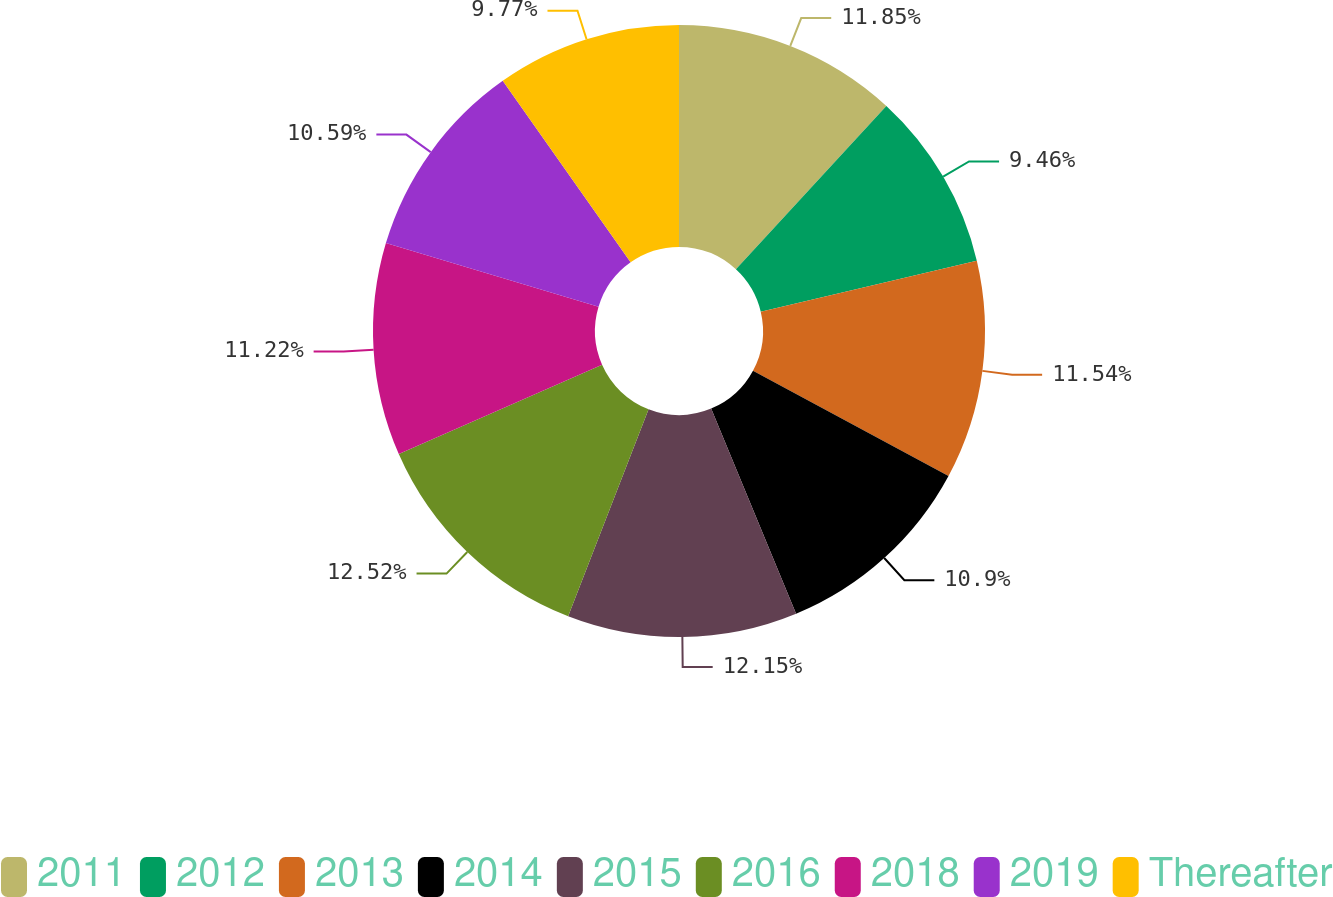<chart> <loc_0><loc_0><loc_500><loc_500><pie_chart><fcel>2011<fcel>2012<fcel>2013<fcel>2014<fcel>2015<fcel>2016<fcel>2018<fcel>2019<fcel>Thereafter<nl><fcel>11.85%<fcel>9.46%<fcel>11.54%<fcel>10.9%<fcel>12.15%<fcel>12.52%<fcel>11.22%<fcel>10.59%<fcel>9.77%<nl></chart> 